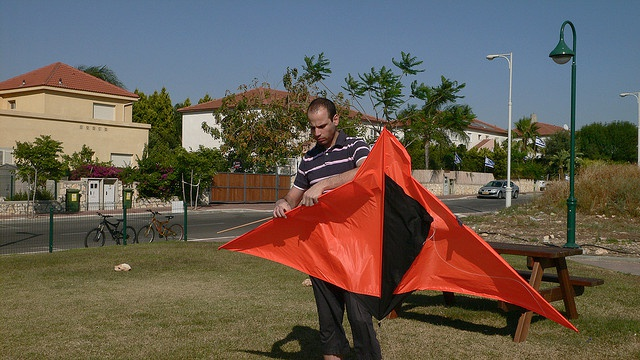Describe the objects in this image and their specific colors. I can see kite in gray, brown, red, and black tones, people in gray, black, and maroon tones, bench in gray, black, and maroon tones, bicycle in gray and black tones, and bicycle in gray, black, maroon, and darkgreen tones in this image. 